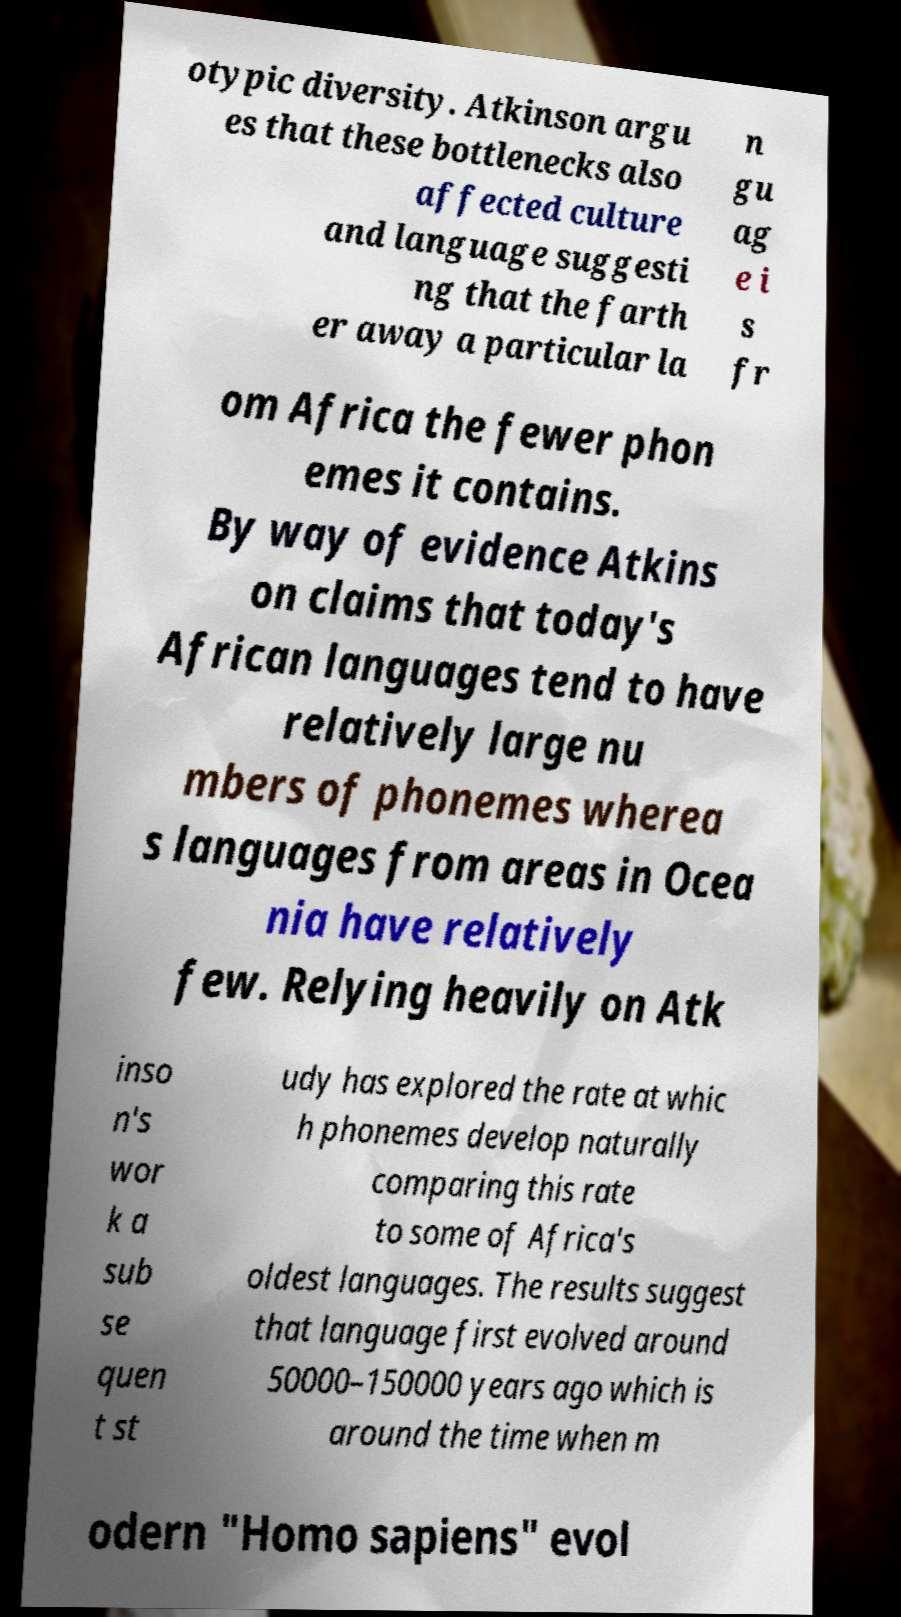What messages or text are displayed in this image? I need them in a readable, typed format. otypic diversity. Atkinson argu es that these bottlenecks also affected culture and language suggesti ng that the farth er away a particular la n gu ag e i s fr om Africa the fewer phon emes it contains. By way of evidence Atkins on claims that today's African languages tend to have relatively large nu mbers of phonemes wherea s languages from areas in Ocea nia have relatively few. Relying heavily on Atk inso n's wor k a sub se quen t st udy has explored the rate at whic h phonemes develop naturally comparing this rate to some of Africa's oldest languages. The results suggest that language first evolved around 50000–150000 years ago which is around the time when m odern "Homo sapiens" evol 